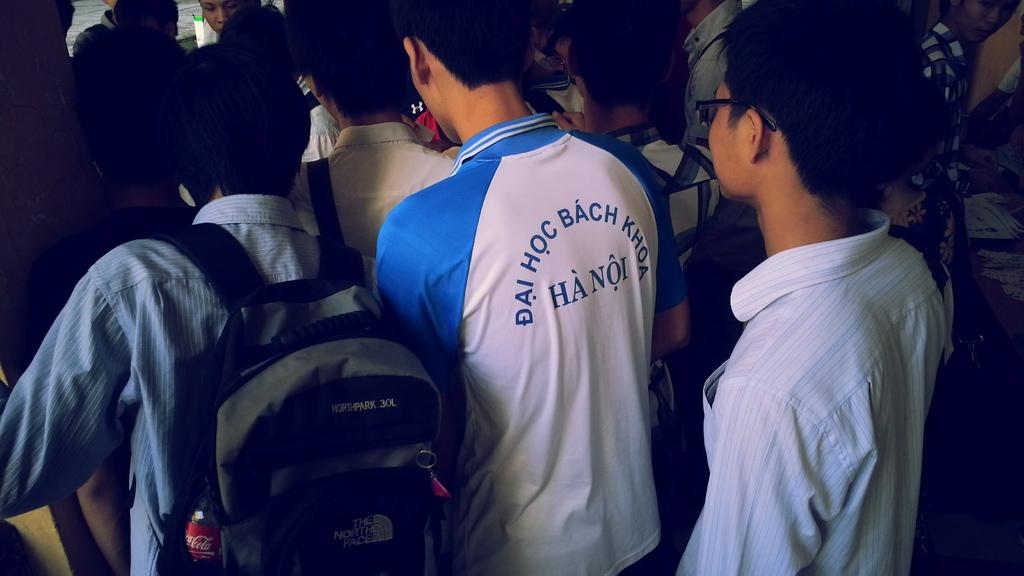Provide a one-sentence caption for the provided image. The city these players are from is Hanoi city. 